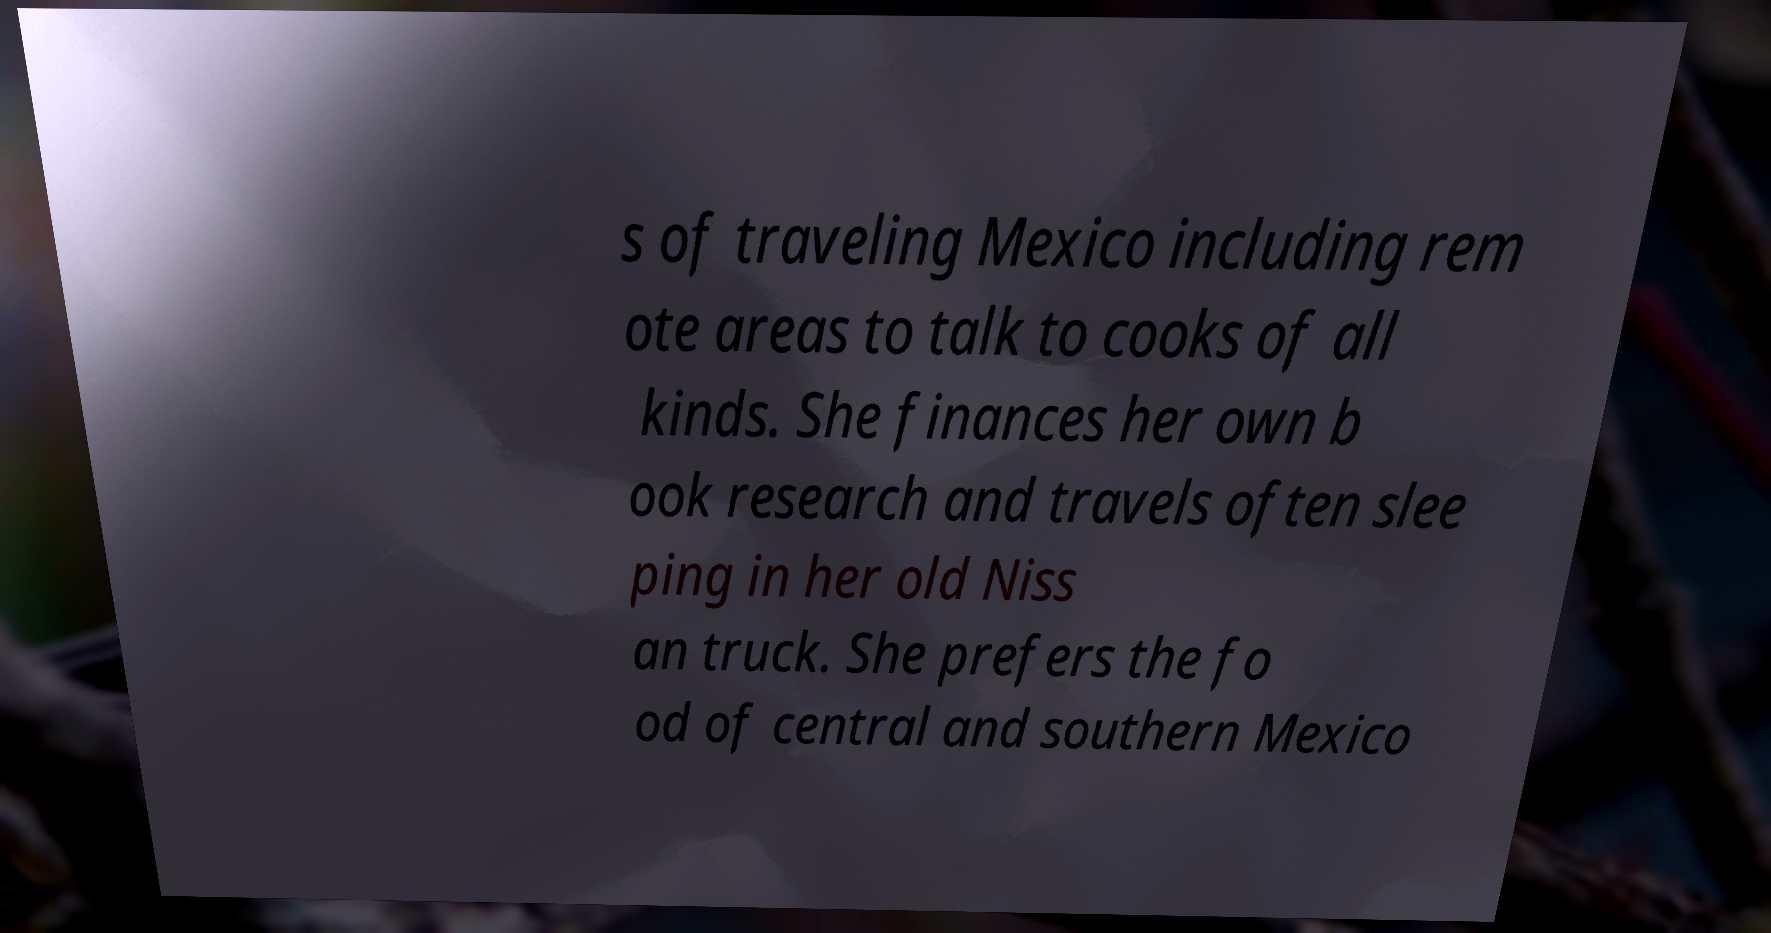There's text embedded in this image that I need extracted. Can you transcribe it verbatim? s of traveling Mexico including rem ote areas to talk to cooks of all kinds. She finances her own b ook research and travels often slee ping in her old Niss an truck. She prefers the fo od of central and southern Mexico 